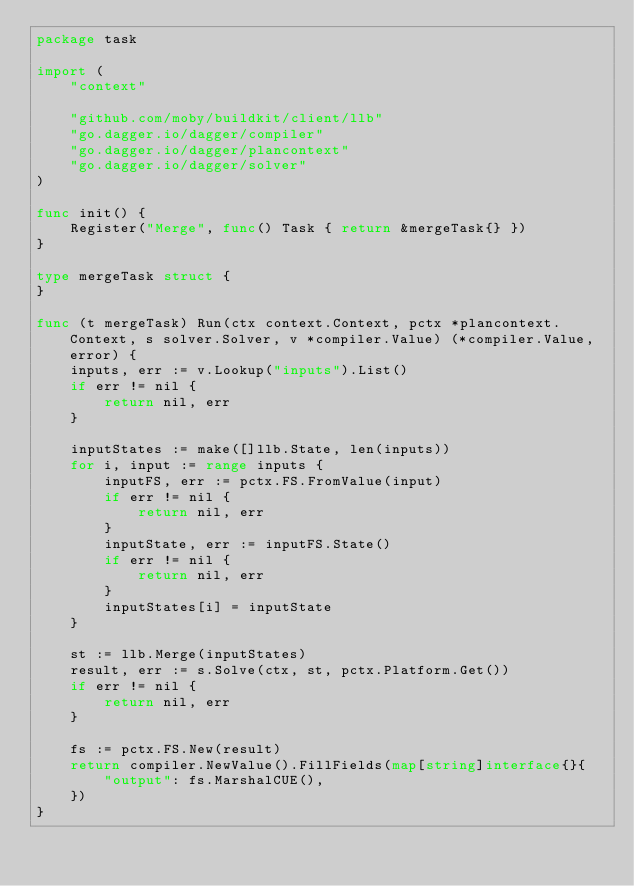<code> <loc_0><loc_0><loc_500><loc_500><_Go_>package task

import (
	"context"

	"github.com/moby/buildkit/client/llb"
	"go.dagger.io/dagger/compiler"
	"go.dagger.io/dagger/plancontext"
	"go.dagger.io/dagger/solver"
)

func init() {
	Register("Merge", func() Task { return &mergeTask{} })
}

type mergeTask struct {
}

func (t mergeTask) Run(ctx context.Context, pctx *plancontext.Context, s solver.Solver, v *compiler.Value) (*compiler.Value, error) {
	inputs, err := v.Lookup("inputs").List()
	if err != nil {
		return nil, err
	}

	inputStates := make([]llb.State, len(inputs))
	for i, input := range inputs {
		inputFS, err := pctx.FS.FromValue(input)
		if err != nil {
			return nil, err
		}
		inputState, err := inputFS.State()
		if err != nil {
			return nil, err
		}
		inputStates[i] = inputState
	}

	st := llb.Merge(inputStates)
	result, err := s.Solve(ctx, st, pctx.Platform.Get())
	if err != nil {
		return nil, err
	}

	fs := pctx.FS.New(result)
	return compiler.NewValue().FillFields(map[string]interface{}{
		"output": fs.MarshalCUE(),
	})
}
</code> 